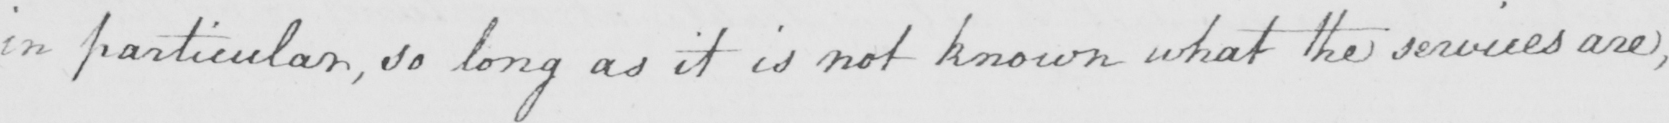Transcribe the text shown in this historical manuscript line. in particular , so long as it is not known what the services are , 